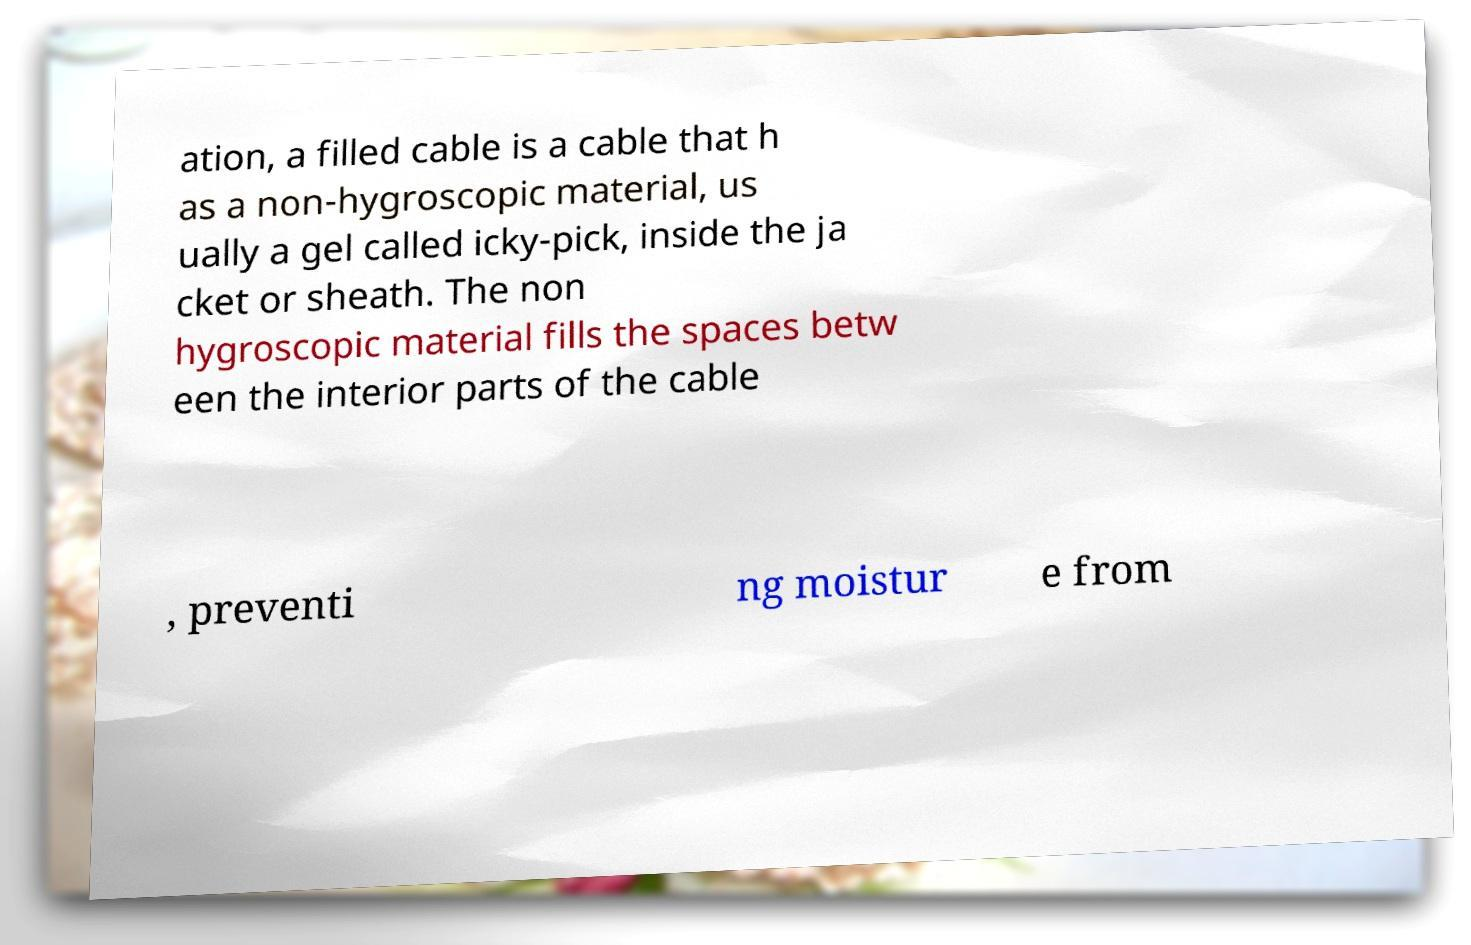I need the written content from this picture converted into text. Can you do that? ation, a filled cable is a cable that h as a non-hygroscopic material, us ually a gel called icky-pick, inside the ja cket or sheath. The non hygroscopic material fills the spaces betw een the interior parts of the cable , preventi ng moistur e from 